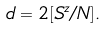<formula> <loc_0><loc_0><loc_500><loc_500>d = 2 [ S ^ { z } / N ] .</formula> 